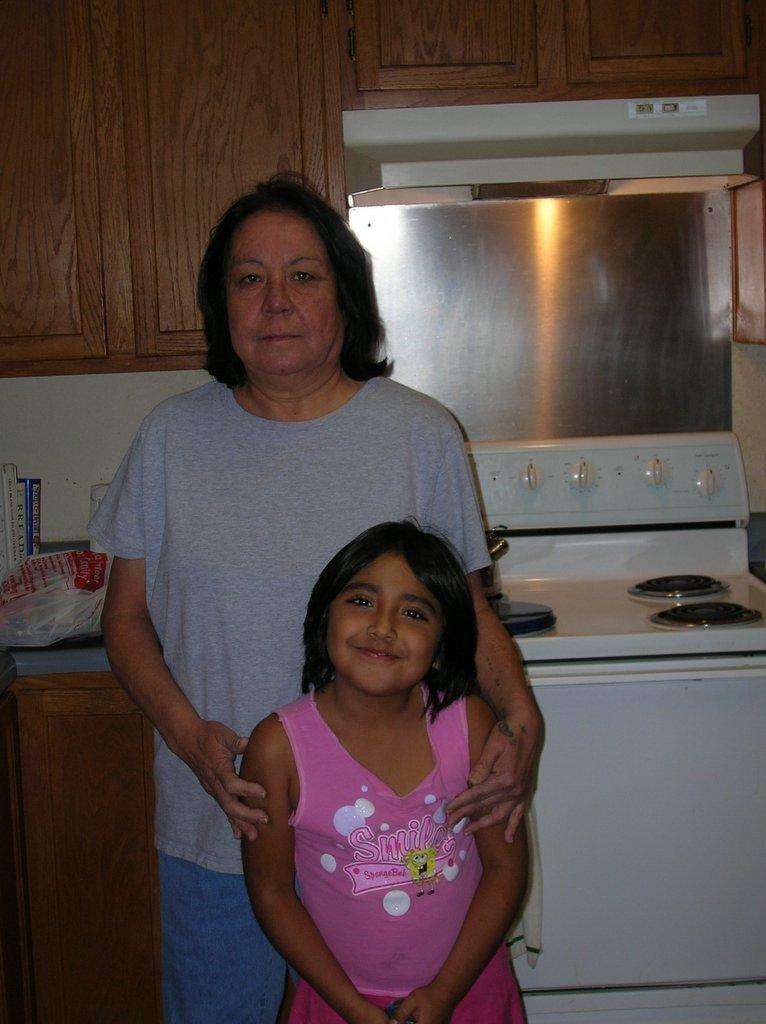Provide a one-sentence caption for the provided image. On the counter there is a Bread cookbook between two other books. 